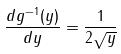<formula> <loc_0><loc_0><loc_500><loc_500>\frac { d g ^ { - 1 } ( y ) } { d y } = \frac { 1 } { 2 \sqrt { y } }</formula> 